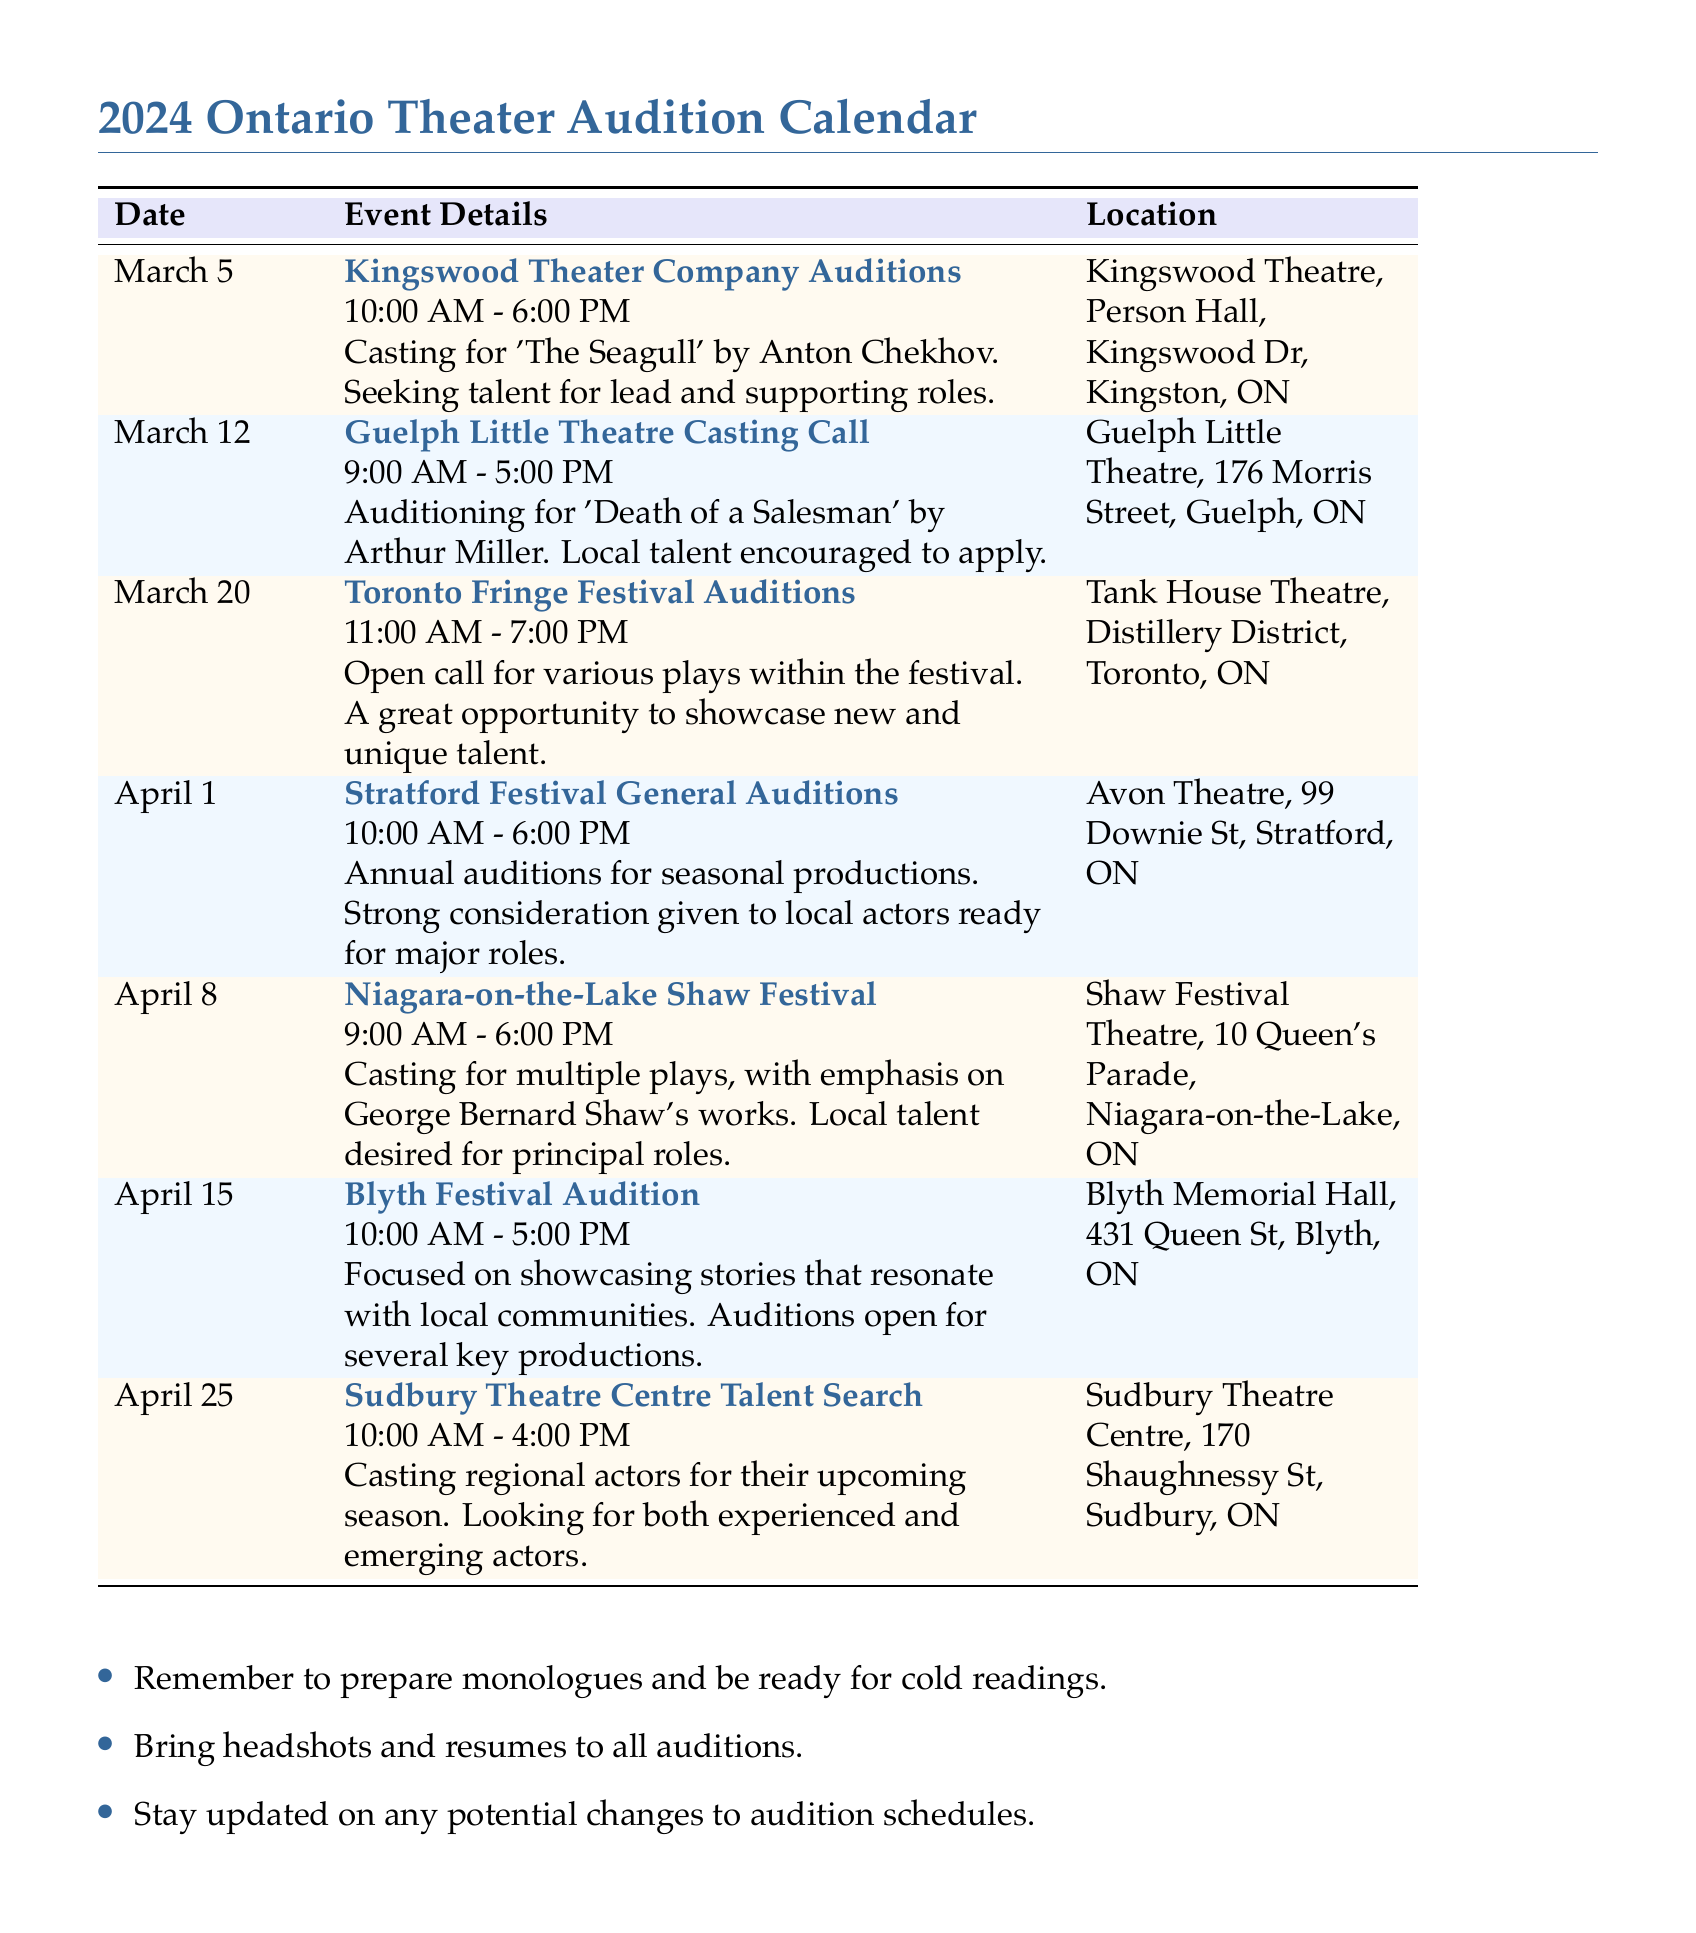What is the date of the Kingswood Theater Company Auditions? The date is explicitly mentioned in the document under the event details for the Kingswood Theater Company Auditions.
Answer: March 5 What play is being auditioned for at Guelph Little Theatre? The document states that the Guelph Little Theatre is auditioning for 'Death of a Salesman'.
Answer: Death of a Salesman What is the time for the Toronto Fringe Festival Auditions? The document specifies that the auditions are from 11:00 AM to 7:00 PM.
Answer: 11:00 AM - 7:00 PM Which theater is hosting the Stratford Festival General Auditions? The document lists Avon Theatre as the location for the Stratford Festival General Auditions.
Answer: Avon Theatre How many auditions are scheduled in April? The document lists the events sequentially in April, allowing for a count of the auditions during that month.
Answer: Four What type of talent is the Niagara-on-the-Lake Shaw Festival looking for? It is specified in the document that they are looking for local talent for principal roles.
Answer: Local talent What location is the Blyth Festival Audition taking place? The document provides a clear venue address for Blyth Festival Audition.
Answer: Blyth Memorial Hall What time does the Sudbury Theatre Centre Talent Search start? The document explicitly states the start time for the Sudbury Theatre Centre Talent Search.
Answer: 10:00 AM 